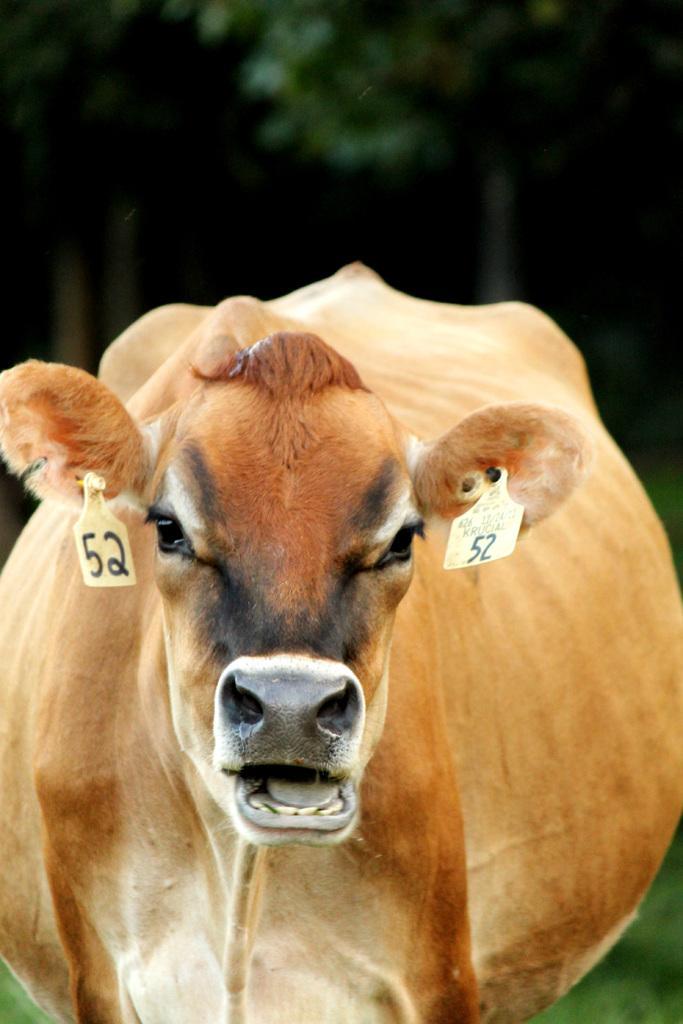Could you give a brief overview of what you see in this image? As we can see in the image in the front there is a cow and the background is dark. 